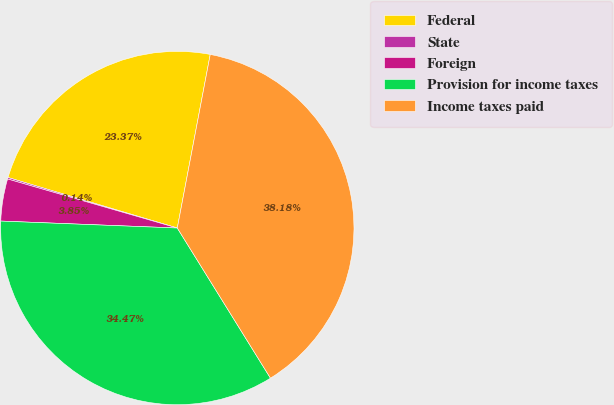Convert chart. <chart><loc_0><loc_0><loc_500><loc_500><pie_chart><fcel>Federal<fcel>State<fcel>Foreign<fcel>Provision for income taxes<fcel>Income taxes paid<nl><fcel>23.37%<fcel>0.14%<fcel>3.85%<fcel>34.47%<fcel>38.18%<nl></chart> 